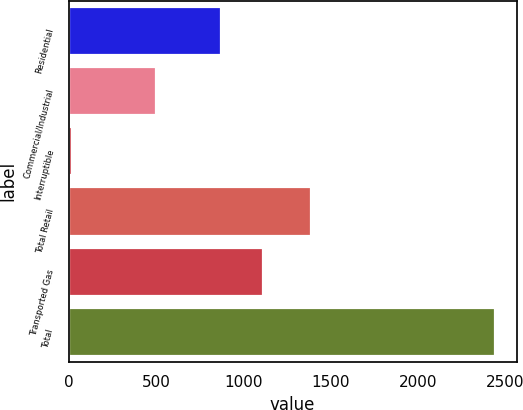<chart> <loc_0><loc_0><loc_500><loc_500><bar_chart><fcel>Residential<fcel>Commercial/Industrial<fcel>Interruptible<fcel>Total Retail<fcel>Transported Gas<fcel>Total<nl><fcel>872<fcel>499.9<fcel>18.1<fcel>1390<fcel>1114.47<fcel>2442.8<nl></chart> 